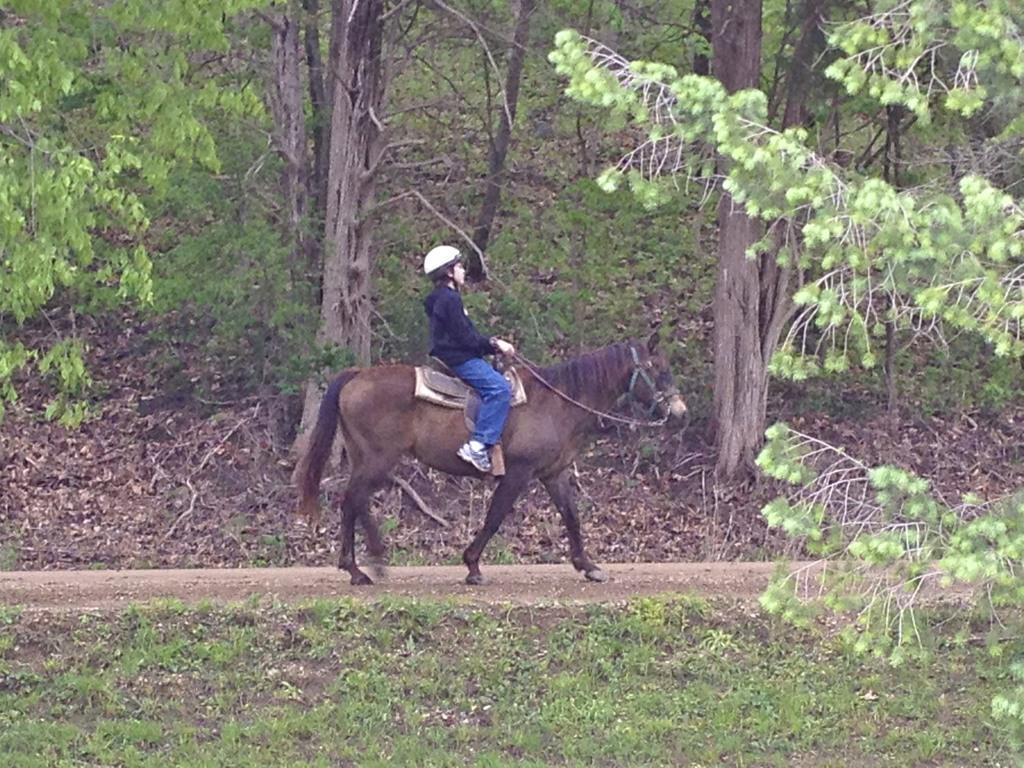In one or two sentences, can you explain what this image depicts? In this image I see the grass over here and I see a person who is sitting on this horse and I see number of trees and I see the path. 